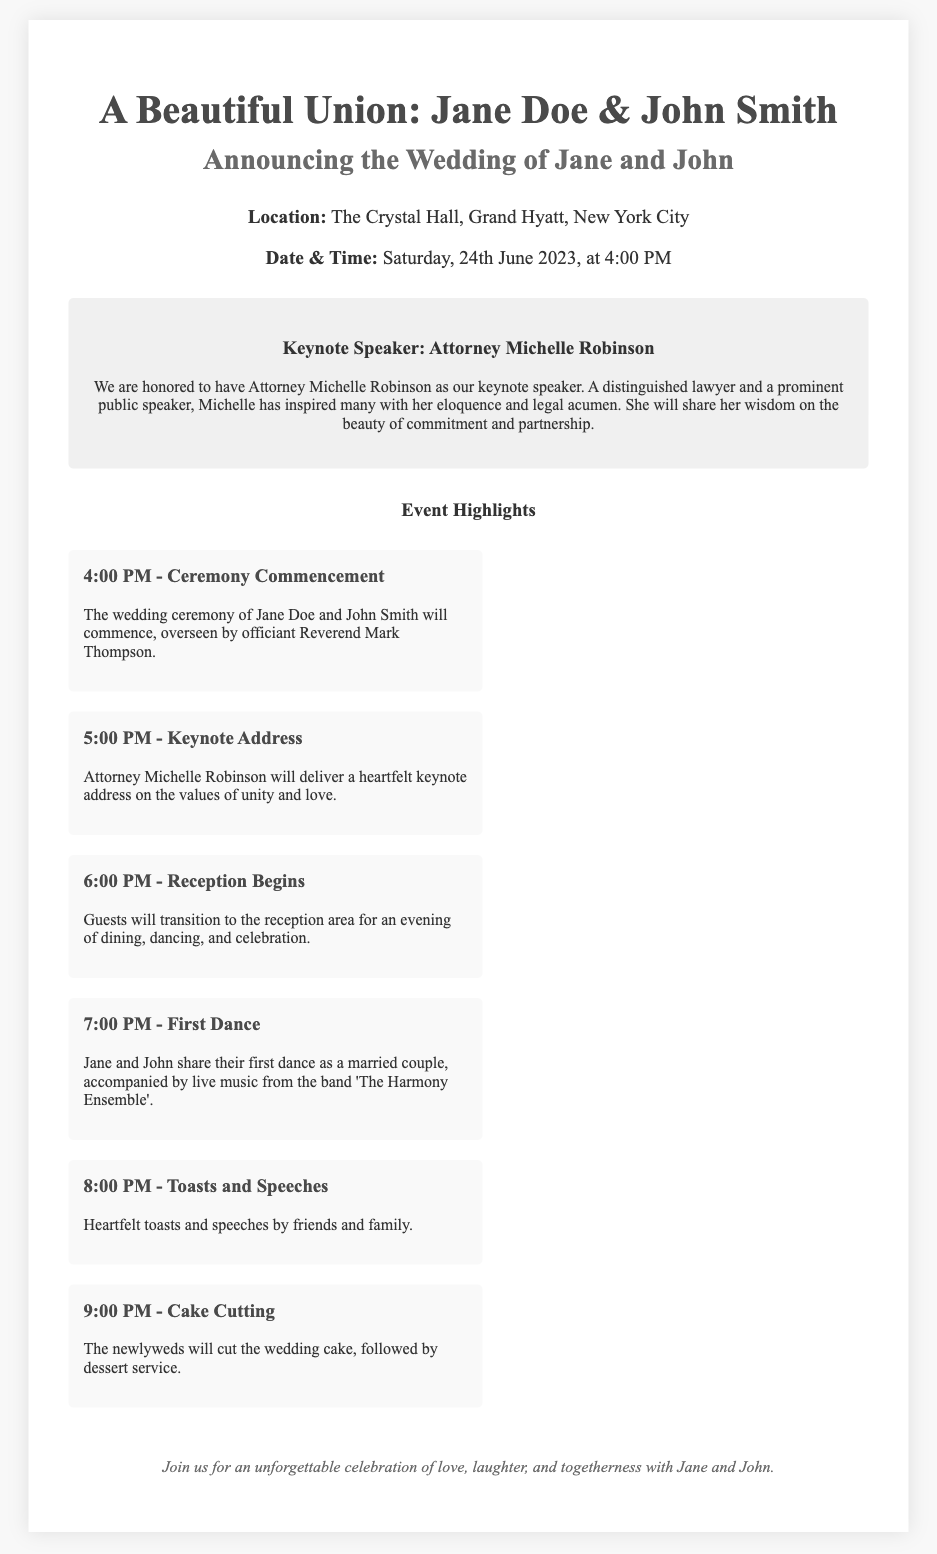What is the name of the bride? The bride's name is mentioned in the invitation as Jane Doe.
Answer: Jane Doe What is the date of the wedding? The date of the wedding is specified in the document, which is Saturday, 24th June 2023.
Answer: 24th June 2023 Who is the keynote speaker? The document states the keynote speaker is Attorney Michelle Robinson.
Answer: Attorney Michelle Robinson What time does the ceremony commence? The time for the ceremony commencement is given as 4:00 PM in the document.
Answer: 4:00 PM What is the first event after the wedding ceremony? The first event after the ceremony is the keynote address delivered by Attorney Michelle Robinson at 5:00 PM.
Answer: Keynote Address What is the location of the wedding? The location for the wedding is provided in the invitation as The Crystal Hall, Grand Hyatt, New York City.
Answer: The Crystal Hall, Grand Hyatt, New York City How many event highlights are listed? The document outlines a total of six event highlights throughout the evening.
Answer: Six What is the closing message of the invitation? The document includes a closing message inviting guests to celebrate love, laughter, and togetherness with Jane and John.
Answer: An unforgettable celebration of love, laughter, and togetherness Who oversees the wedding ceremony? The officiant for the wedding ceremony is Reverend Mark Thompson according to the document.
Answer: Reverend Mark Thompson 